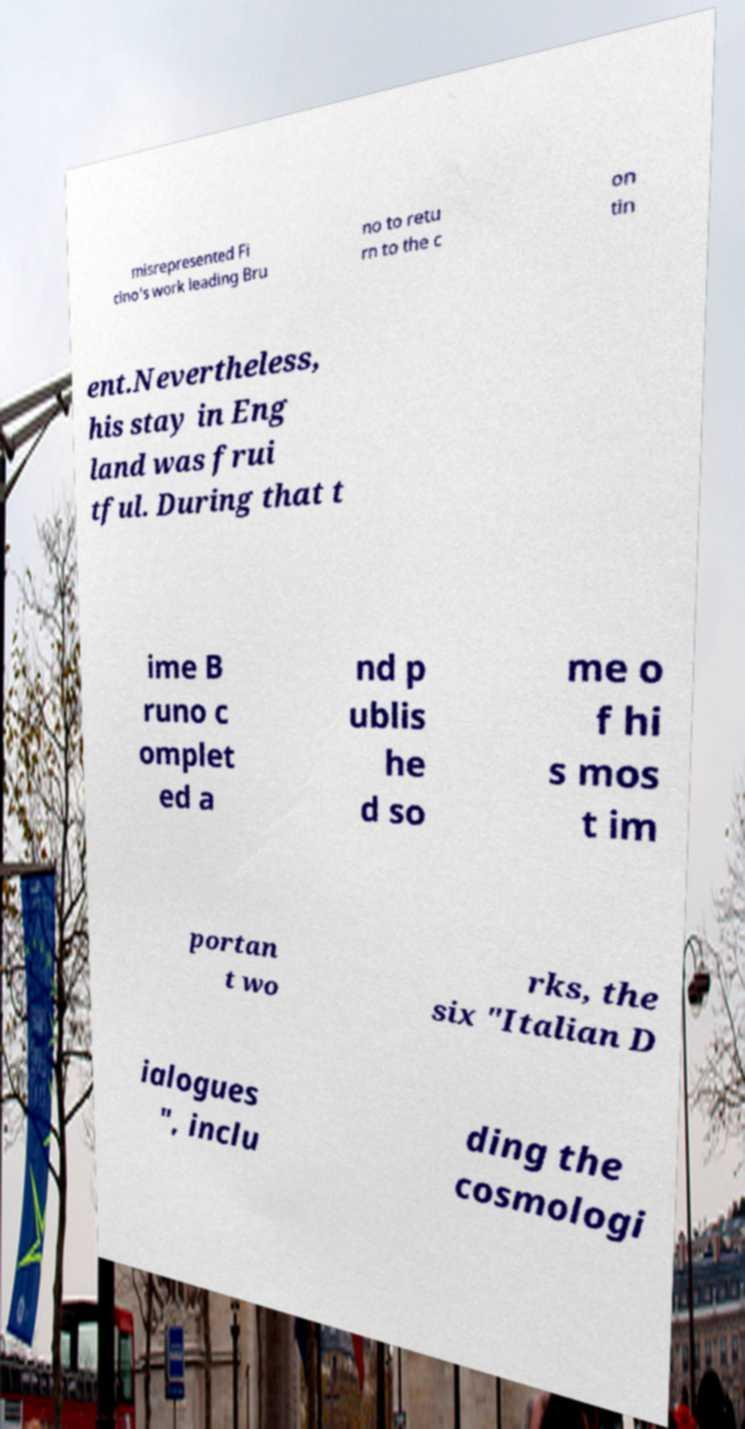Could you assist in decoding the text presented in this image and type it out clearly? misrepresented Fi cino's work leading Bru no to retu rn to the c on tin ent.Nevertheless, his stay in Eng land was frui tful. During that t ime B runo c omplet ed a nd p ublis he d so me o f hi s mos t im portan t wo rks, the six "Italian D ialogues ", inclu ding the cosmologi 